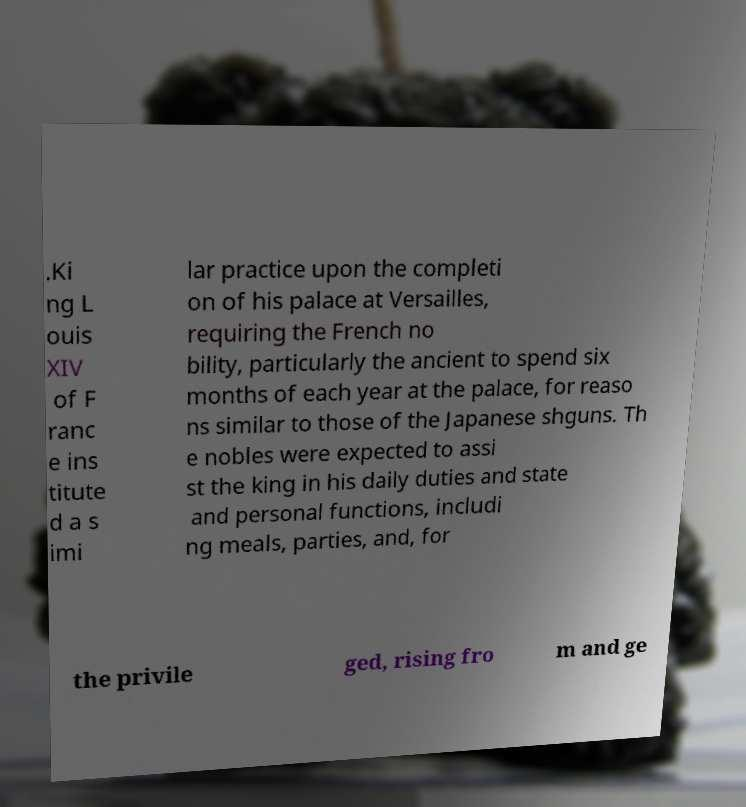Can you accurately transcribe the text from the provided image for me? .Ki ng L ouis XIV of F ranc e ins titute d a s imi lar practice upon the completi on of his palace at Versailles, requiring the French no bility, particularly the ancient to spend six months of each year at the palace, for reaso ns similar to those of the Japanese shguns. Th e nobles were expected to assi st the king in his daily duties and state and personal functions, includi ng meals, parties, and, for the privile ged, rising fro m and ge 